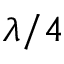Convert formula to latex. <formula><loc_0><loc_0><loc_500><loc_500>\lambda / 4</formula> 